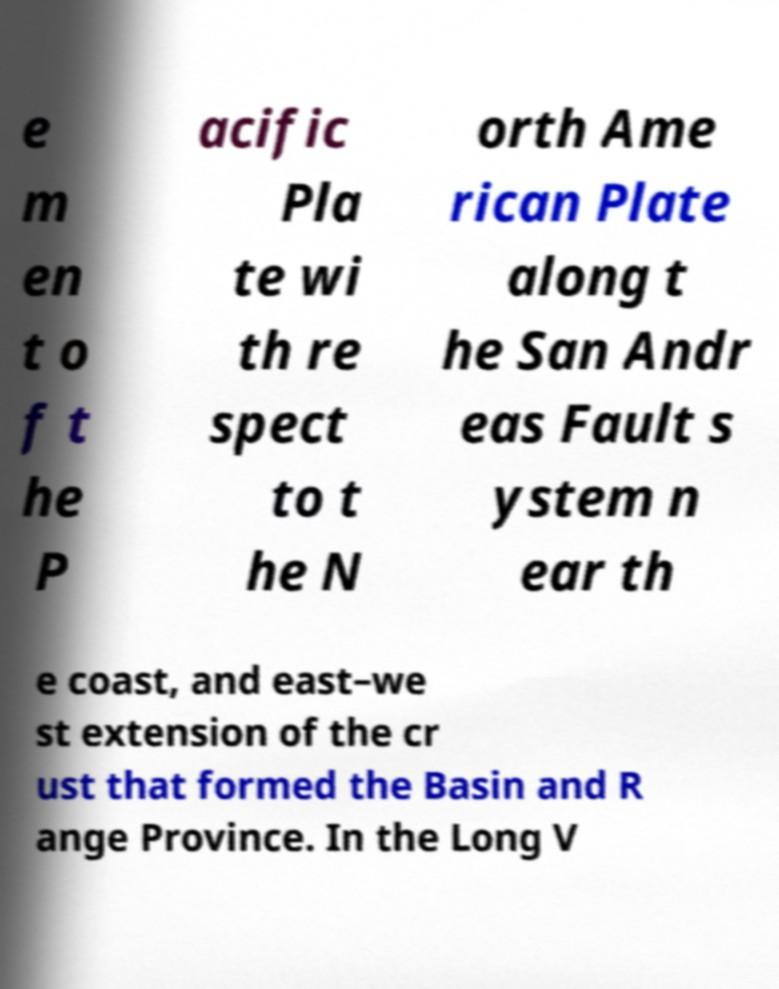What messages or text are displayed in this image? I need them in a readable, typed format. e m en t o f t he P acific Pla te wi th re spect to t he N orth Ame rican Plate along t he San Andr eas Fault s ystem n ear th e coast, and east–we st extension of the cr ust that formed the Basin and R ange Province. In the Long V 